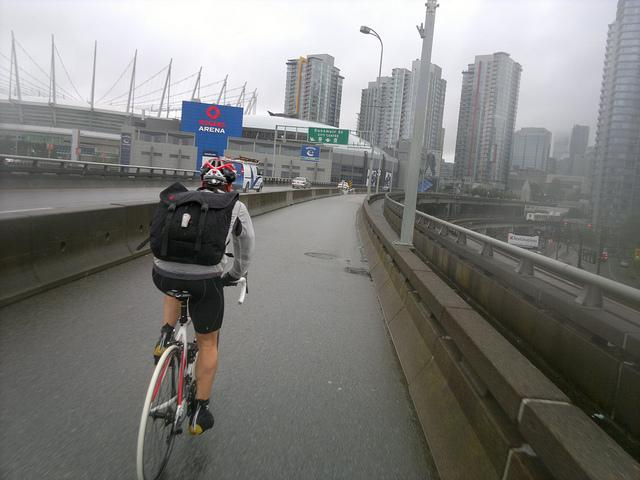What vehicles are allowed on the rightmost lane?

Choices:
A) cars
B) trucks
C) vans
D) bicycles bicycles 